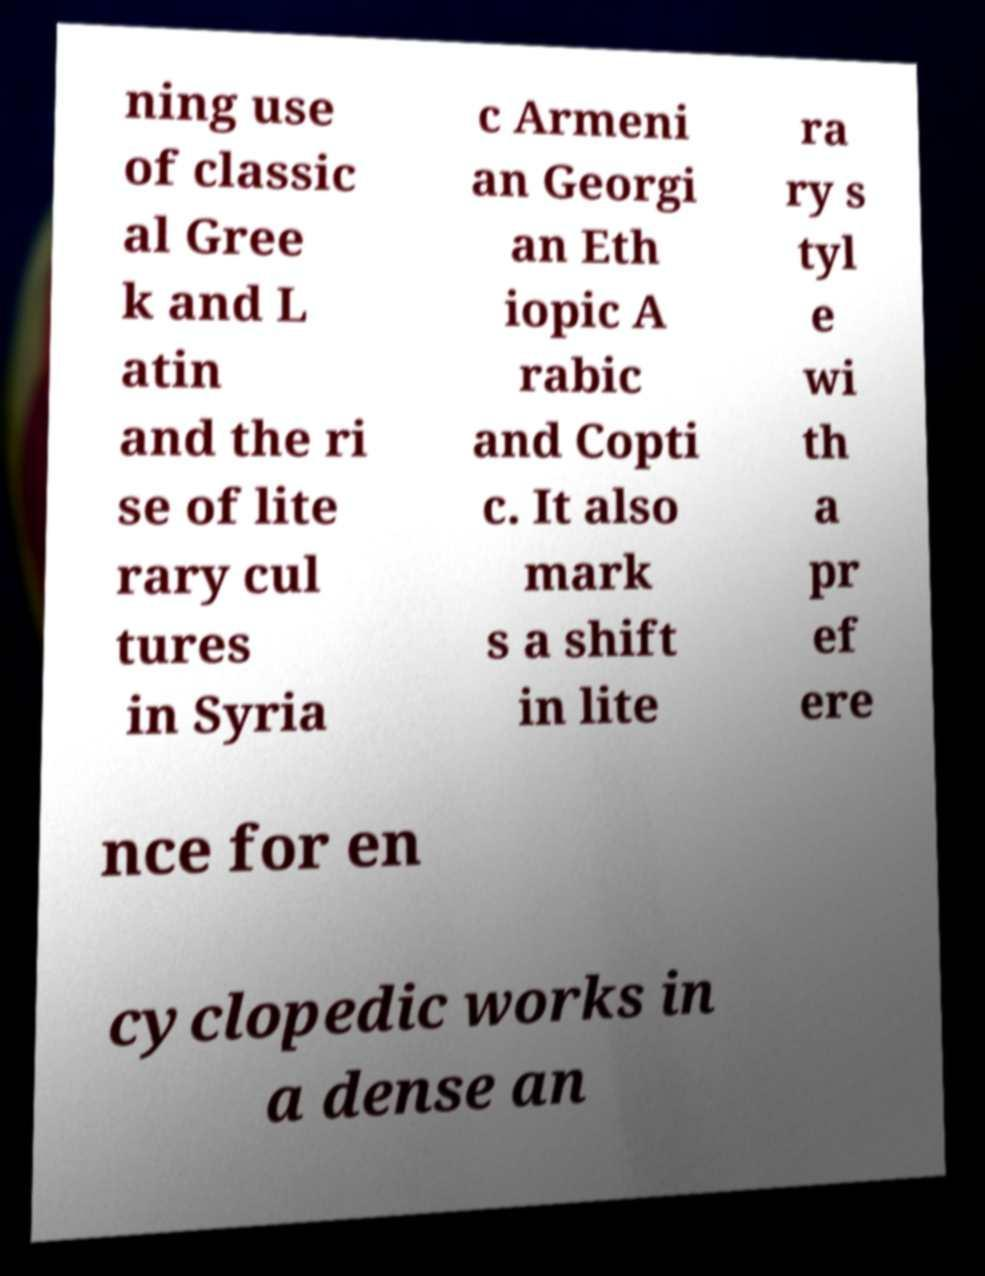I need the written content from this picture converted into text. Can you do that? ning use of classic al Gree k and L atin and the ri se of lite rary cul tures in Syria c Armeni an Georgi an Eth iopic A rabic and Copti c. It also mark s a shift in lite ra ry s tyl e wi th a pr ef ere nce for en cyclopedic works in a dense an 